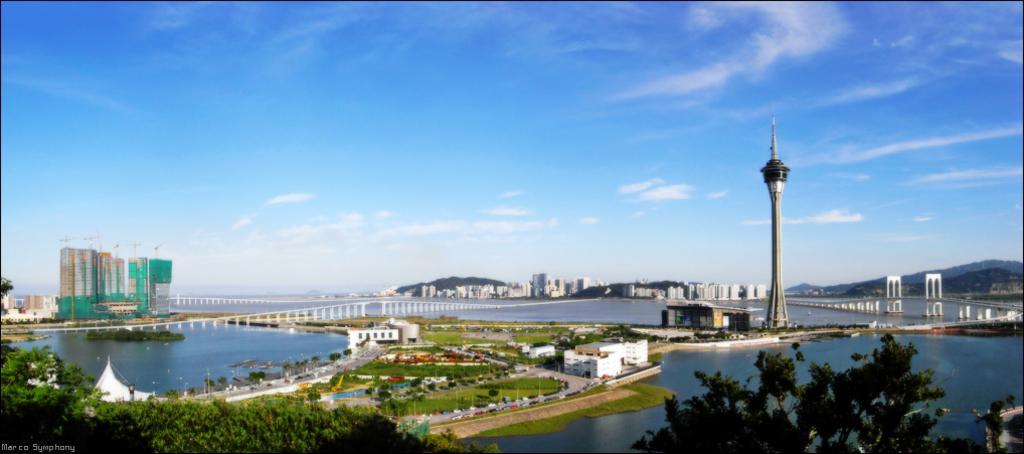Could you give a brief overview of what you see in this image? This image is clicked from a top view. In the center there are buildings, trees and roads. There are vehicles moving on the road. Beside the road there are poles. There is grass on the ground. Around it there is the water. To the right there are mountains. Beside it there is a bridge on the water. There is a tower in the image. To the left there are buildings. In the background there are mountains and buildings. At the top there is the sky. At the bottom there are trees. In the bottom left there is the text on the image. 